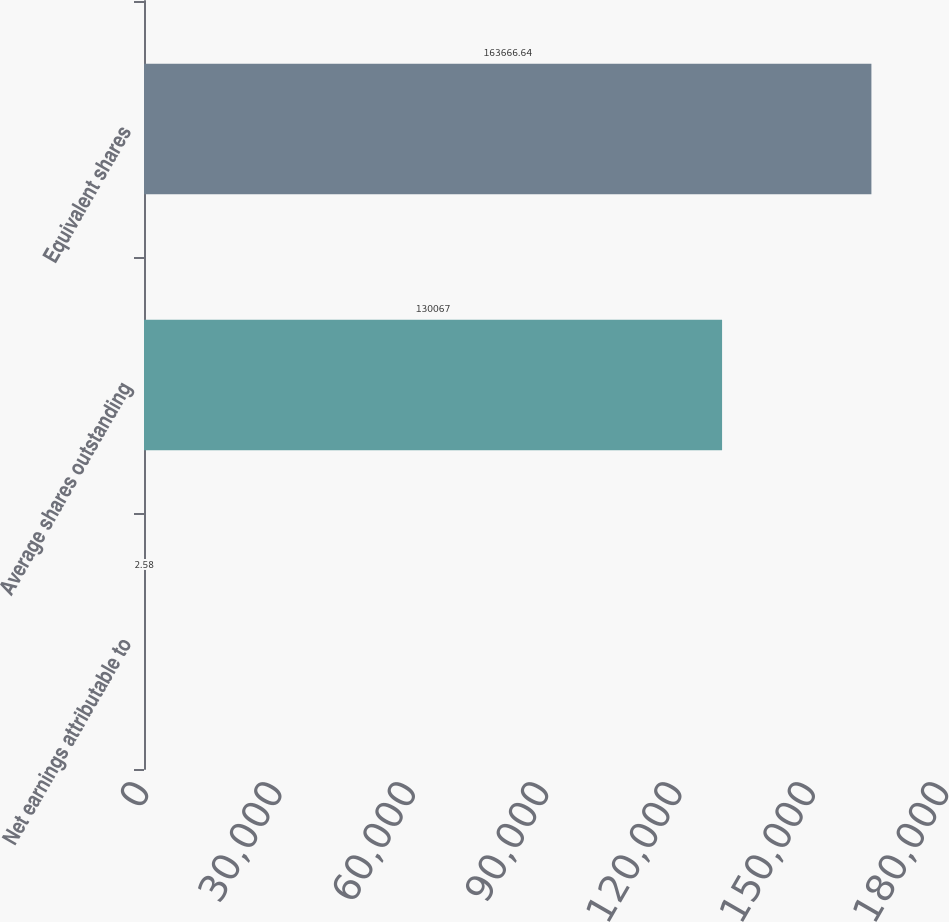Convert chart to OTSL. <chart><loc_0><loc_0><loc_500><loc_500><bar_chart><fcel>Net earnings attributable to<fcel>Average shares outstanding<fcel>Equivalent shares<nl><fcel>2.58<fcel>130067<fcel>163667<nl></chart> 